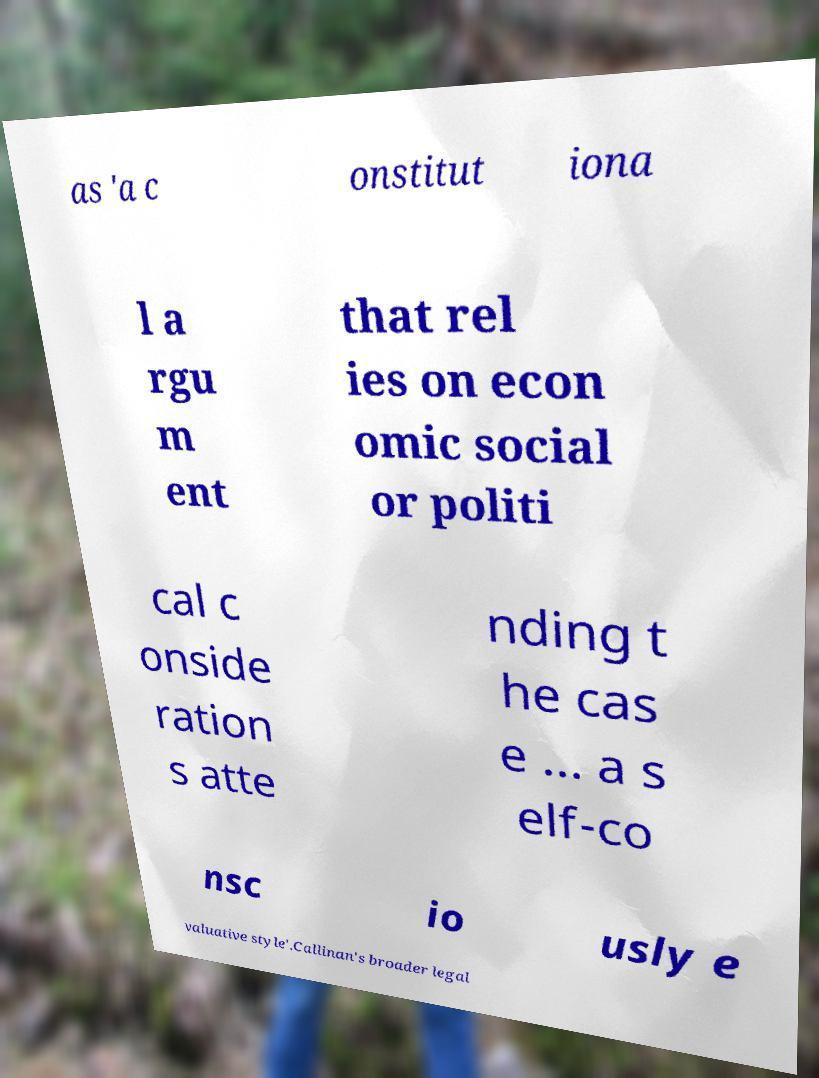There's text embedded in this image that I need extracted. Can you transcribe it verbatim? as 'a c onstitut iona l a rgu m ent that rel ies on econ omic social or politi cal c onside ration s atte nding t he cas e ... a s elf-co nsc io usly e valuative style'.Callinan's broader legal 